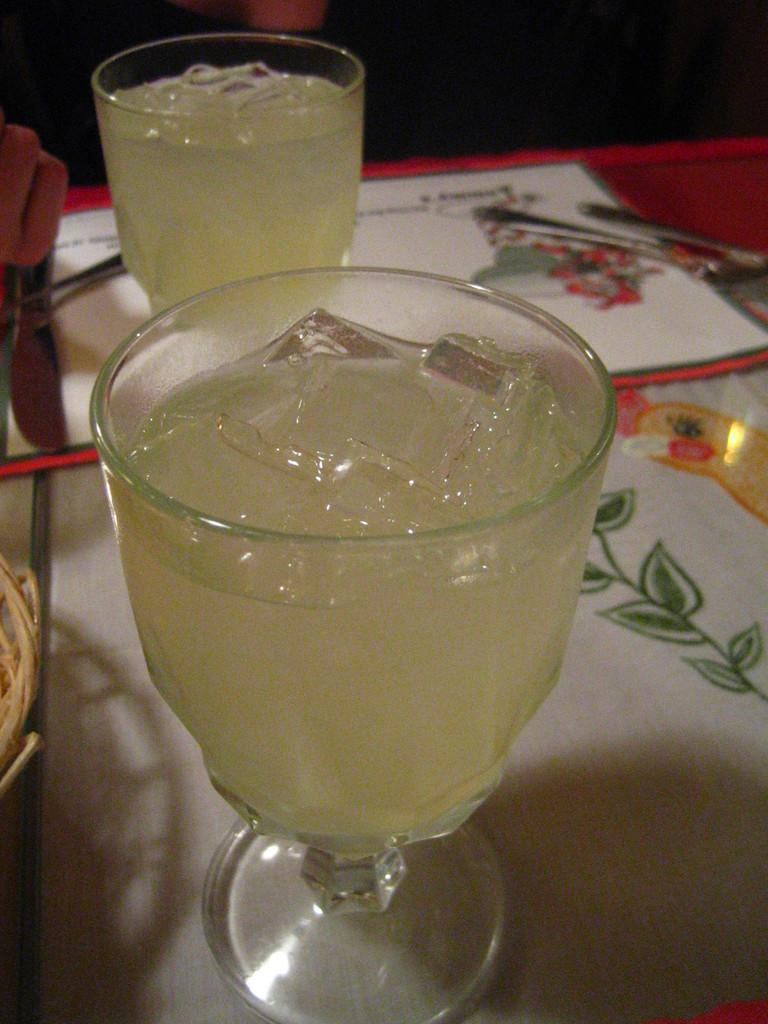What objects are present in the image that are typically used for drinking? There are glasses in the image. What can be seen on the left side of the image? There is a cloth on the left side of the image. What type of container is visible in the image? There is a basket in the image. Where are the spoons located in the image? The spoons are on a table in the image. What type of zephyr can be seen blowing through the basket in the image? There is no zephyr present in the image, and the basket is not depicted as being affected by any wind. 